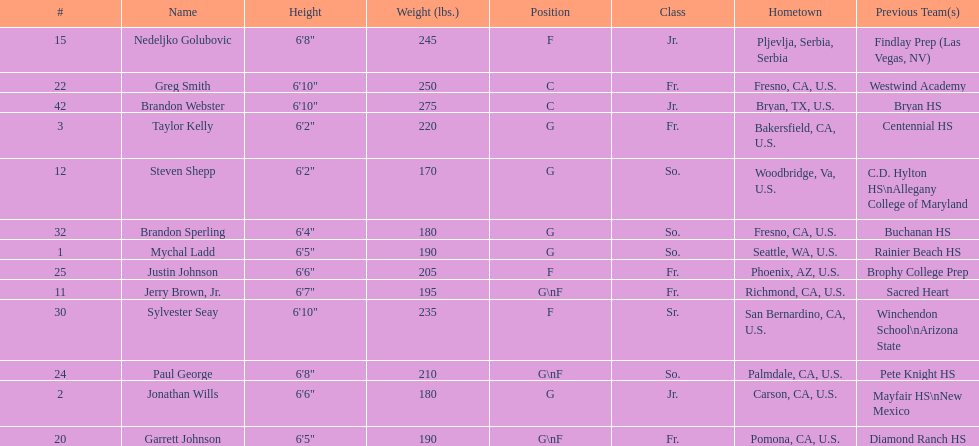Who is the only player not from the u. s.? Nedeljko Golubovic. 